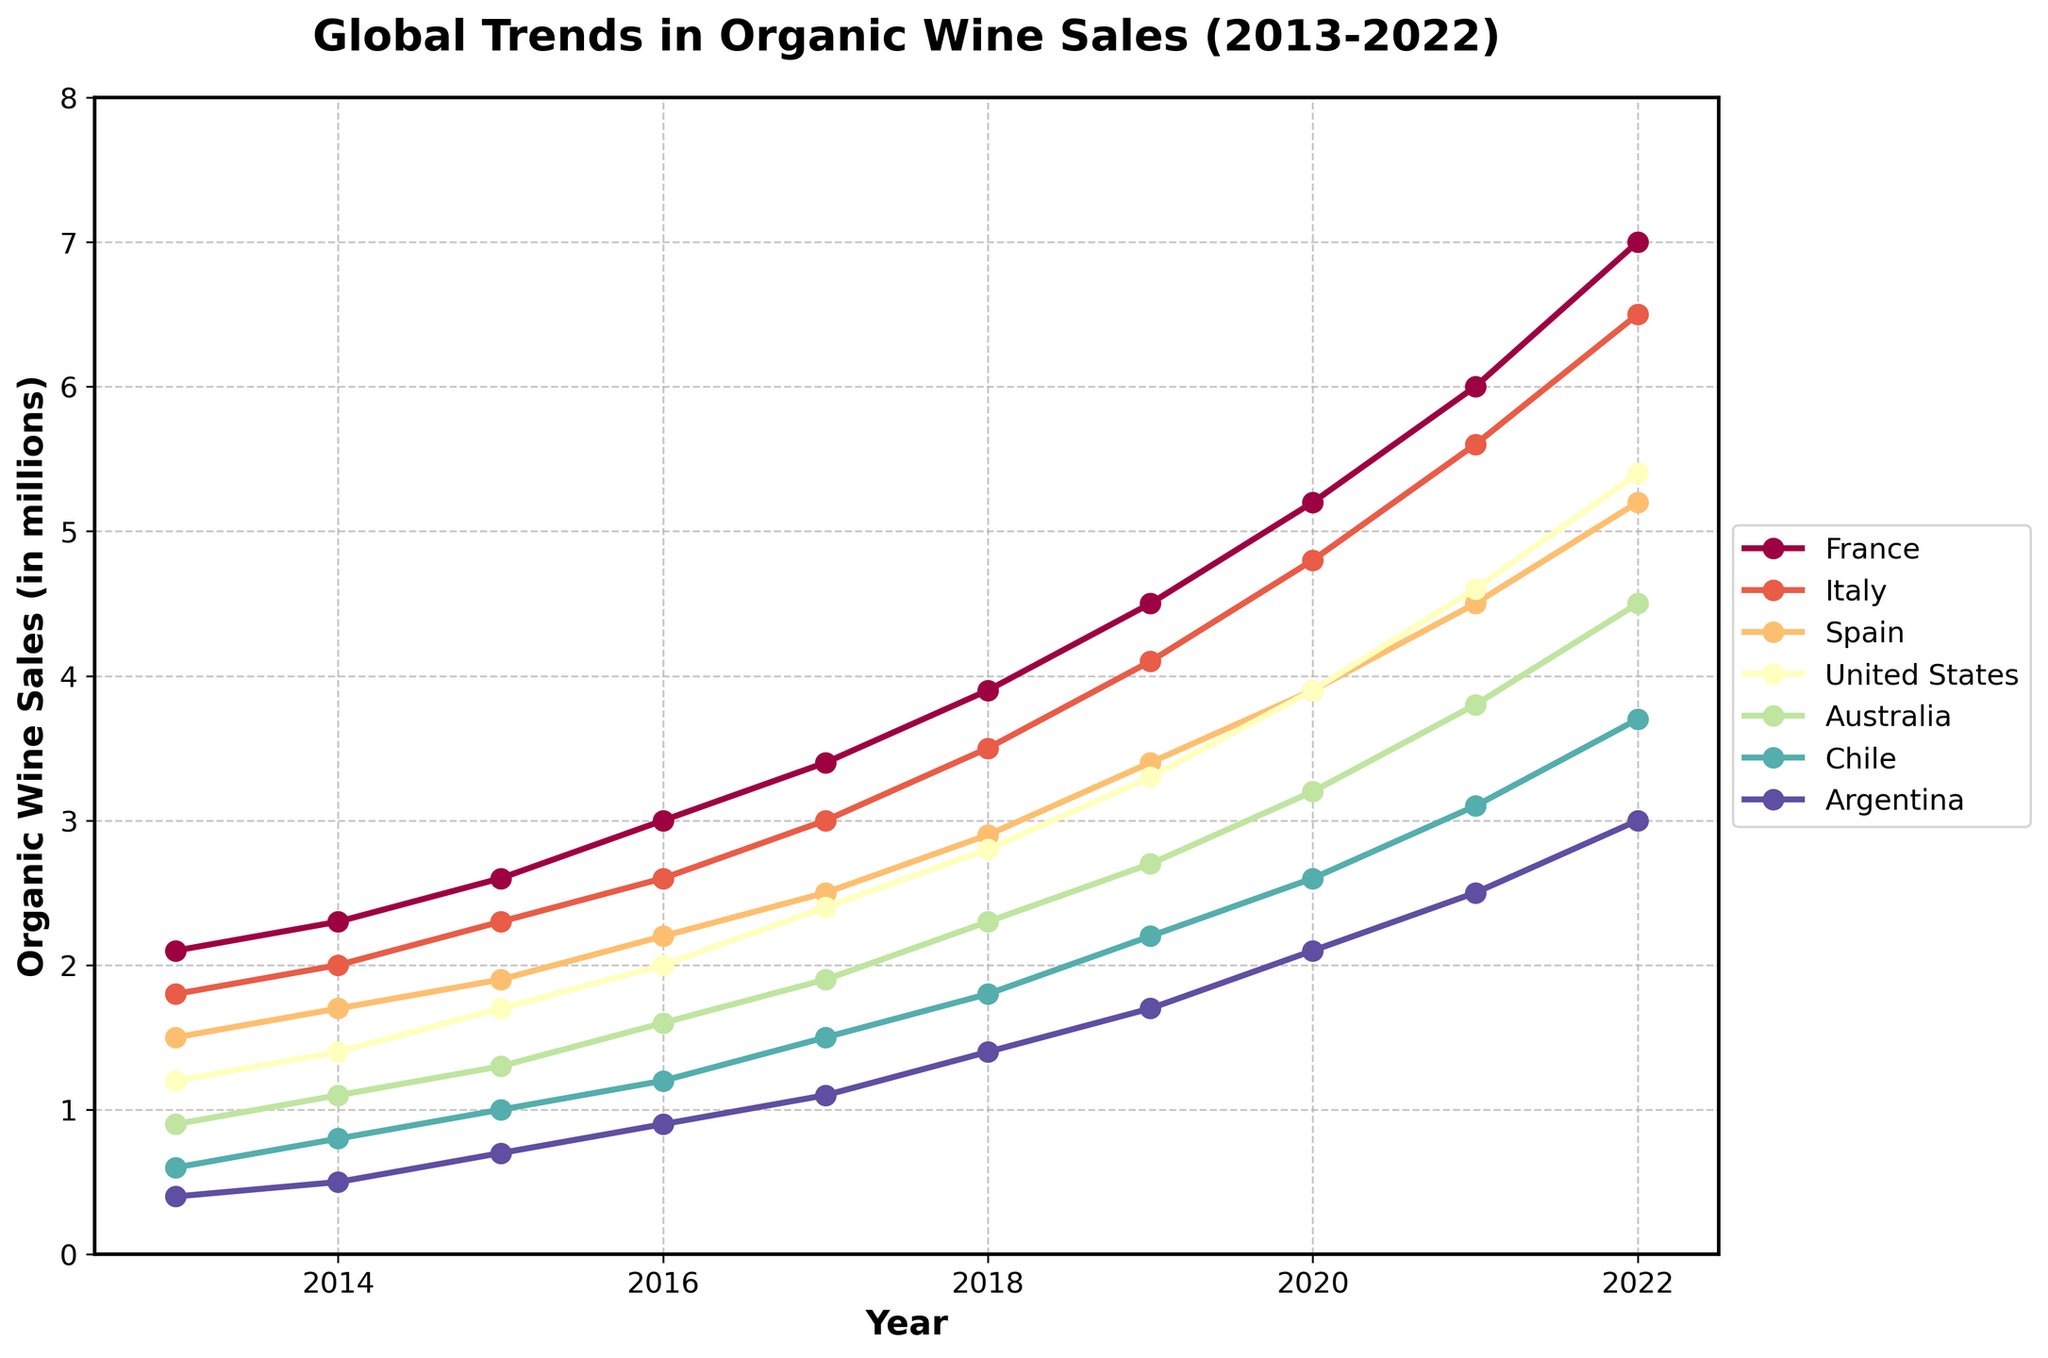What year did France first surpass 5 million in organic wine sales? To find the first year, look along France's trend line and identify where it crosses the 5 million mark. According to the data, this happened in 2020.
Answer: 2020 Which country had the smallest growth in organic wine sales from 2013 to 2022? Calculate the difference between 2013 and 2022 sales for each country. France: 7.0-2.1=4.9, Italy: 6.5-1.8=4.7, Spain: 5.2-1.5=3.7, US: 5.4-1.2=4.2, Australia: 4.5-0.9=3.6, Chile: 3.7-0.6=3.1, Argentina: 3.0-0.4=2.6. Argentina shows the smallest increase.
Answer: Argentina In which year did Italy's organic wine sales surpass 4 million? Look for the year where Italy's trend line intersects with the 4 million mark. According to the data, this occurs in 2019.
Answer: 2019 By how much did Spain's organic wine sales increase between 2017 and 2022? Find Spain's organic wine sales for 2017 (2.5) and 2022 (5.2), and calculate the difference: 5.2 - 2.5 = 2.7.
Answer: 2.7 Which two countries had the closest organic wine sales in 2020? Compare the country sales values for 2020: France: 5.2, Italy: 4.8, Spain: 3.9, US: 3.9, Australia: 3.2, Chile: 2.6, Argentina: 2.1. The US and Spain both have a value of 3.9, making them the closest.
Answer: United States and Spain What is the average annual increase in organic wine sales for Chile from 2013 to 2022? Calculate Chile's increase over the period (3.7 - 0.6 = 3.1). Then, divide by the number of years (2022 - 2013 = 9): 3.1 / 9 ≈ 0.34.
Answer: 0.34 Which visual element indicates the year 2017 on the line chart? Look at the x-axis to locate the position labeled 2017, then find the vertical line extending upward intersecting various trend lines.
Answer: Position of the x-axis labeled 2017 During which period did Australia see the most rapid increase in organic wine sales? Look for the steepest upward slope on Australia’s trend line. The segment between 2018 and 2021 shows the most rapid increase: 3.8 - 2.3 = 1.5 over 3 years.
Answer: 2018-2021 